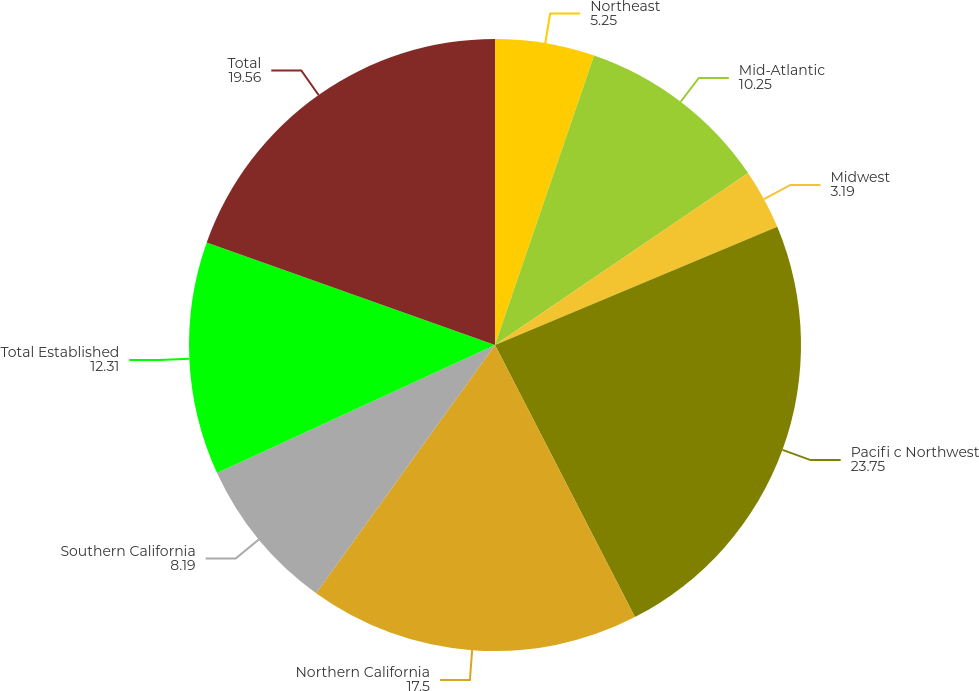Convert chart to OTSL. <chart><loc_0><loc_0><loc_500><loc_500><pie_chart><fcel>Northeast<fcel>Mid-Atlantic<fcel>Midwest<fcel>Pacifi c Northwest<fcel>Northern California<fcel>Southern California<fcel>Total Established<fcel>Total<nl><fcel>5.25%<fcel>10.25%<fcel>3.19%<fcel>23.75%<fcel>17.5%<fcel>8.19%<fcel>12.31%<fcel>19.56%<nl></chart> 